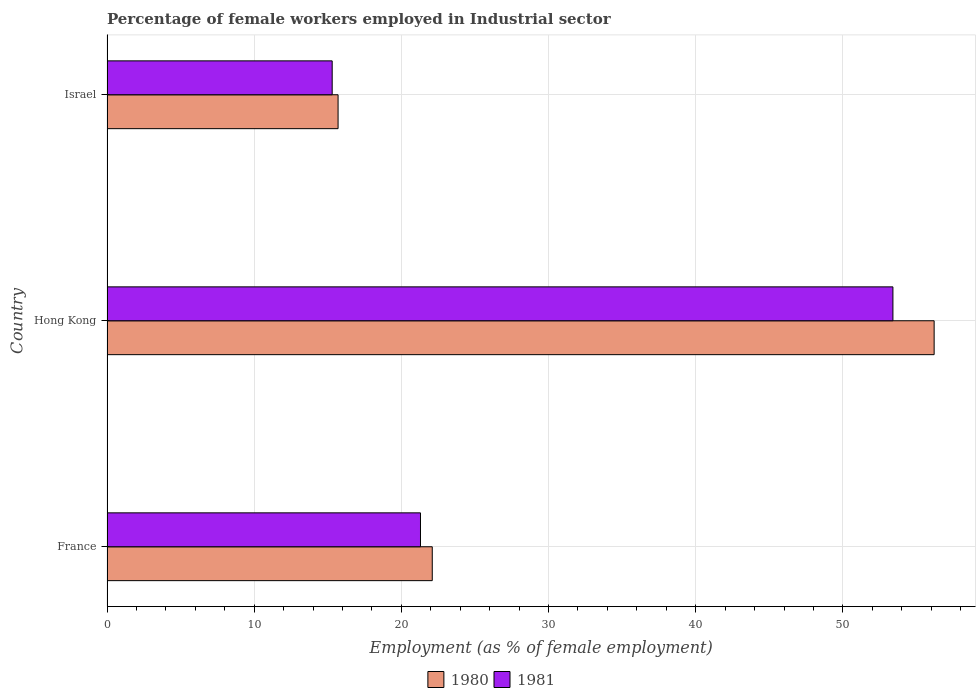How many different coloured bars are there?
Give a very brief answer. 2. Are the number of bars on each tick of the Y-axis equal?
Your answer should be very brief. Yes. How many bars are there on the 3rd tick from the top?
Keep it short and to the point. 2. How many bars are there on the 1st tick from the bottom?
Ensure brevity in your answer.  2. What is the label of the 2nd group of bars from the top?
Offer a terse response. Hong Kong. In how many cases, is the number of bars for a given country not equal to the number of legend labels?
Offer a terse response. 0. What is the percentage of females employed in Industrial sector in 1981 in Hong Kong?
Give a very brief answer. 53.4. Across all countries, what is the maximum percentage of females employed in Industrial sector in 1980?
Your answer should be compact. 56.2. Across all countries, what is the minimum percentage of females employed in Industrial sector in 1981?
Ensure brevity in your answer.  15.3. In which country was the percentage of females employed in Industrial sector in 1980 maximum?
Offer a terse response. Hong Kong. In which country was the percentage of females employed in Industrial sector in 1981 minimum?
Keep it short and to the point. Israel. What is the total percentage of females employed in Industrial sector in 1981 in the graph?
Make the answer very short. 90. What is the difference between the percentage of females employed in Industrial sector in 1980 in France and that in Israel?
Make the answer very short. 6.4. What is the difference between the percentage of females employed in Industrial sector in 1980 in Hong Kong and the percentage of females employed in Industrial sector in 1981 in France?
Your response must be concise. 34.9. What is the average percentage of females employed in Industrial sector in 1981 per country?
Give a very brief answer. 30. What is the difference between the percentage of females employed in Industrial sector in 1980 and percentage of females employed in Industrial sector in 1981 in Israel?
Ensure brevity in your answer.  0.4. In how many countries, is the percentage of females employed in Industrial sector in 1980 greater than 44 %?
Provide a short and direct response. 1. What is the ratio of the percentage of females employed in Industrial sector in 1980 in France to that in Hong Kong?
Ensure brevity in your answer.  0.39. Is the percentage of females employed in Industrial sector in 1980 in France less than that in Hong Kong?
Your answer should be very brief. Yes. Is the difference between the percentage of females employed in Industrial sector in 1980 in Hong Kong and Israel greater than the difference between the percentage of females employed in Industrial sector in 1981 in Hong Kong and Israel?
Your answer should be very brief. Yes. What is the difference between the highest and the second highest percentage of females employed in Industrial sector in 1980?
Make the answer very short. 34.1. What is the difference between the highest and the lowest percentage of females employed in Industrial sector in 1981?
Offer a terse response. 38.1. In how many countries, is the percentage of females employed in Industrial sector in 1981 greater than the average percentage of females employed in Industrial sector in 1981 taken over all countries?
Provide a short and direct response. 1. How many bars are there?
Your response must be concise. 6. Are all the bars in the graph horizontal?
Your answer should be compact. Yes. How many countries are there in the graph?
Provide a short and direct response. 3. What is the difference between two consecutive major ticks on the X-axis?
Keep it short and to the point. 10. Where does the legend appear in the graph?
Ensure brevity in your answer.  Bottom center. How are the legend labels stacked?
Make the answer very short. Horizontal. What is the title of the graph?
Make the answer very short. Percentage of female workers employed in Industrial sector. What is the label or title of the X-axis?
Give a very brief answer. Employment (as % of female employment). What is the Employment (as % of female employment) of 1980 in France?
Offer a terse response. 22.1. What is the Employment (as % of female employment) in 1981 in France?
Provide a short and direct response. 21.3. What is the Employment (as % of female employment) in 1980 in Hong Kong?
Make the answer very short. 56.2. What is the Employment (as % of female employment) in 1981 in Hong Kong?
Offer a terse response. 53.4. What is the Employment (as % of female employment) in 1980 in Israel?
Ensure brevity in your answer.  15.7. What is the Employment (as % of female employment) in 1981 in Israel?
Your answer should be very brief. 15.3. Across all countries, what is the maximum Employment (as % of female employment) in 1980?
Provide a succinct answer. 56.2. Across all countries, what is the maximum Employment (as % of female employment) of 1981?
Offer a very short reply. 53.4. Across all countries, what is the minimum Employment (as % of female employment) of 1980?
Offer a terse response. 15.7. Across all countries, what is the minimum Employment (as % of female employment) of 1981?
Provide a succinct answer. 15.3. What is the total Employment (as % of female employment) in 1980 in the graph?
Offer a terse response. 94. What is the difference between the Employment (as % of female employment) in 1980 in France and that in Hong Kong?
Offer a terse response. -34.1. What is the difference between the Employment (as % of female employment) in 1981 in France and that in Hong Kong?
Give a very brief answer. -32.1. What is the difference between the Employment (as % of female employment) of 1981 in France and that in Israel?
Provide a succinct answer. 6. What is the difference between the Employment (as % of female employment) of 1980 in Hong Kong and that in Israel?
Your response must be concise. 40.5. What is the difference between the Employment (as % of female employment) of 1981 in Hong Kong and that in Israel?
Provide a succinct answer. 38.1. What is the difference between the Employment (as % of female employment) of 1980 in France and the Employment (as % of female employment) of 1981 in Hong Kong?
Your answer should be very brief. -31.3. What is the difference between the Employment (as % of female employment) of 1980 in France and the Employment (as % of female employment) of 1981 in Israel?
Ensure brevity in your answer.  6.8. What is the difference between the Employment (as % of female employment) in 1980 in Hong Kong and the Employment (as % of female employment) in 1981 in Israel?
Your response must be concise. 40.9. What is the average Employment (as % of female employment) of 1980 per country?
Offer a very short reply. 31.33. What is the average Employment (as % of female employment) of 1981 per country?
Offer a very short reply. 30. What is the difference between the Employment (as % of female employment) in 1980 and Employment (as % of female employment) in 1981 in France?
Ensure brevity in your answer.  0.8. What is the difference between the Employment (as % of female employment) in 1980 and Employment (as % of female employment) in 1981 in Hong Kong?
Your response must be concise. 2.8. What is the difference between the Employment (as % of female employment) in 1980 and Employment (as % of female employment) in 1981 in Israel?
Make the answer very short. 0.4. What is the ratio of the Employment (as % of female employment) of 1980 in France to that in Hong Kong?
Make the answer very short. 0.39. What is the ratio of the Employment (as % of female employment) in 1981 in France to that in Hong Kong?
Your answer should be compact. 0.4. What is the ratio of the Employment (as % of female employment) in 1980 in France to that in Israel?
Offer a very short reply. 1.41. What is the ratio of the Employment (as % of female employment) in 1981 in France to that in Israel?
Your response must be concise. 1.39. What is the ratio of the Employment (as % of female employment) of 1980 in Hong Kong to that in Israel?
Offer a very short reply. 3.58. What is the ratio of the Employment (as % of female employment) in 1981 in Hong Kong to that in Israel?
Ensure brevity in your answer.  3.49. What is the difference between the highest and the second highest Employment (as % of female employment) of 1980?
Ensure brevity in your answer.  34.1. What is the difference between the highest and the second highest Employment (as % of female employment) of 1981?
Ensure brevity in your answer.  32.1. What is the difference between the highest and the lowest Employment (as % of female employment) of 1980?
Your response must be concise. 40.5. What is the difference between the highest and the lowest Employment (as % of female employment) in 1981?
Make the answer very short. 38.1. 